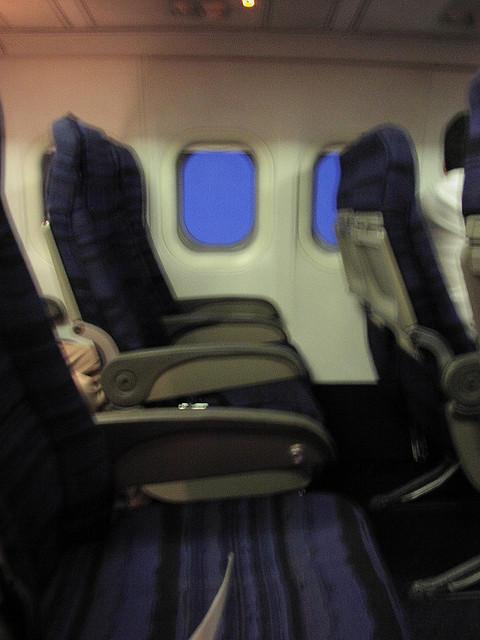Is this inside a plane?
Concise answer only. Yes. Are the windows open?
Be succinct. No. What kind of vehicle is this person in?
Give a very brief answer. Plane. Are the curtains blocking the sunlight from entering through the windows?
Be succinct. No. Could this be at a motel?
Keep it brief. No. What does this man plan on doing?
Write a very short answer. Flying. What is in the picture?
Give a very brief answer. Seats. Is this a lobby?
Short answer required. No. Are there any people in the photo?
Short answer required. No. 